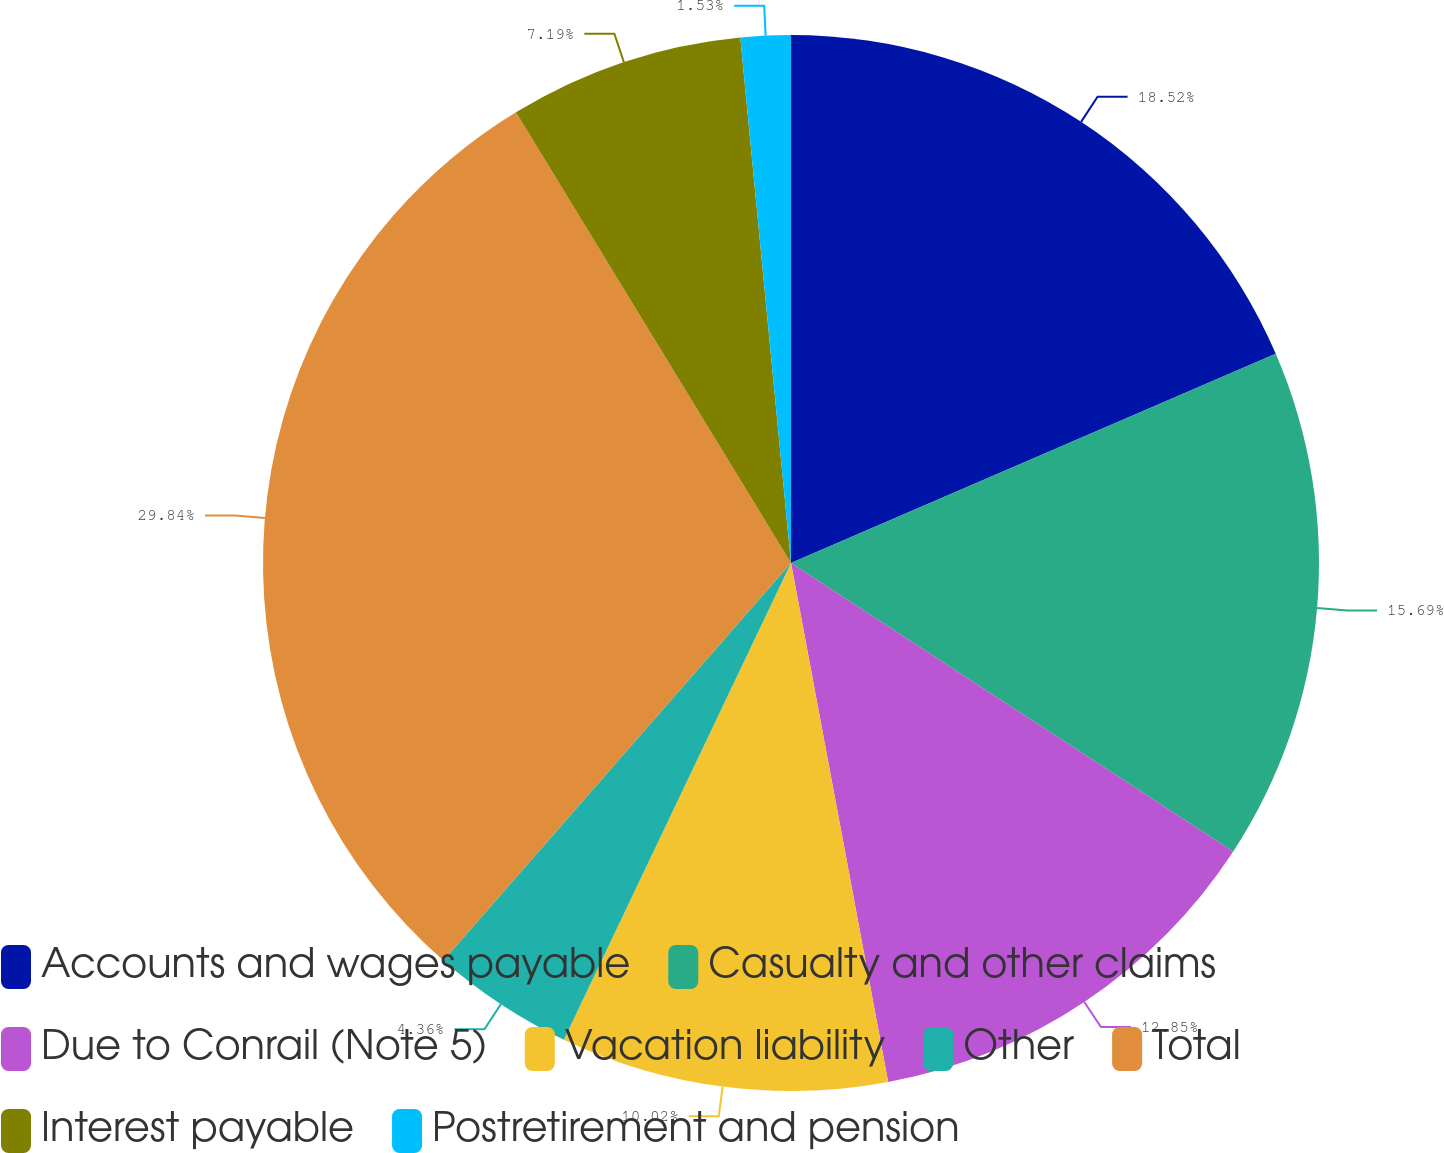<chart> <loc_0><loc_0><loc_500><loc_500><pie_chart><fcel>Accounts and wages payable<fcel>Casualty and other claims<fcel>Due to Conrail (Note 5)<fcel>Vacation liability<fcel>Other<fcel>Total<fcel>Interest payable<fcel>Postretirement and pension<nl><fcel>18.51%<fcel>15.68%<fcel>12.85%<fcel>10.02%<fcel>4.36%<fcel>29.83%<fcel>7.19%<fcel>1.53%<nl></chart> 